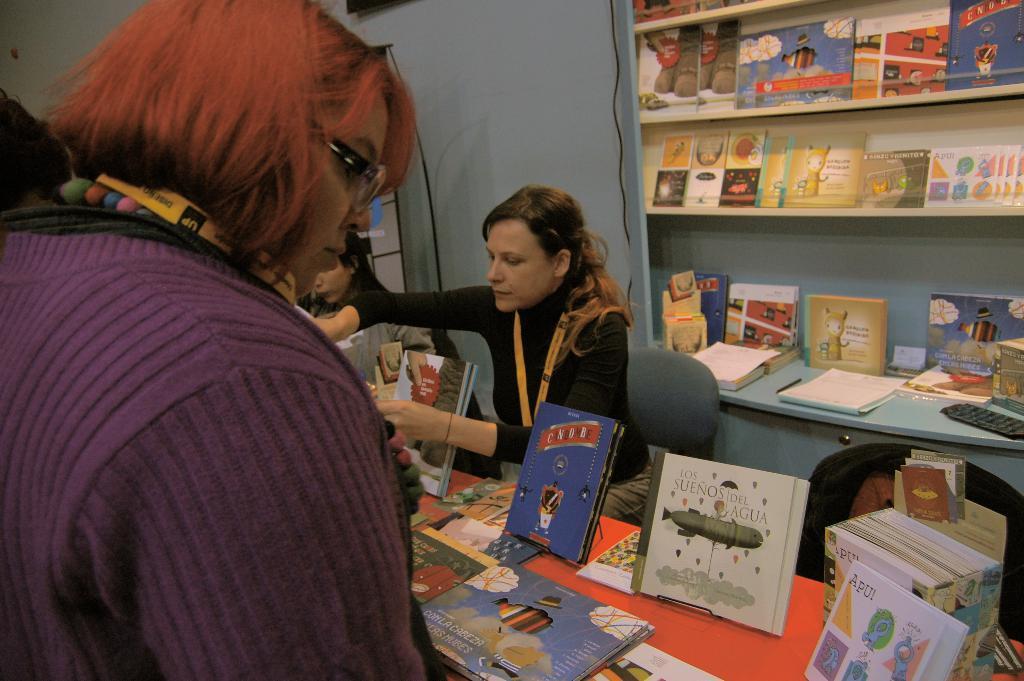In one or two sentences, can you explain what this image depicts? This image is taken indoors. On the left side of the image there is a woman. At the bottom of the image there is a table with many books on it. In the middle of the image a woman is sitting on the chair and she is holding a few books in her hands. In the background there is a wall and a cupboard with shelves and many books on it. 